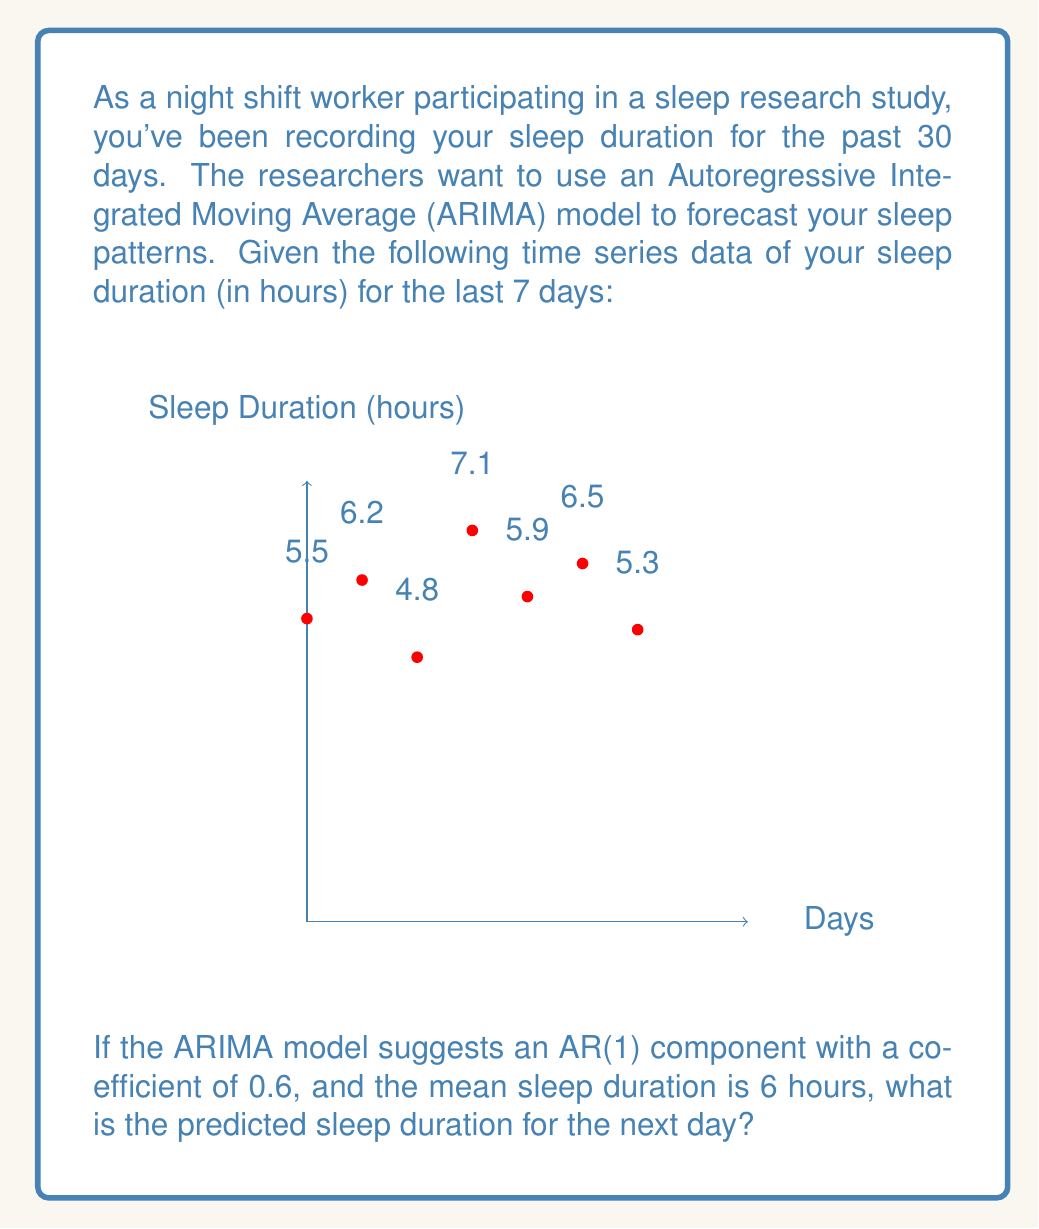What is the answer to this math problem? To solve this problem, we'll use the AR(1) model, which is a component of the ARIMA model. The AR(1) model is given by the equation:

$$ X_t = \mu + \phi(X_{t-1} - \mu) + \epsilon_t $$

Where:
- $X_t$ is the predicted value at time t
- $\mu$ is the mean of the time series
- $\phi$ is the AR(1) coefficient
- $X_{t-1}$ is the previous observed value
- $\epsilon_t$ is the error term (which we assume to be 0 for prediction)

Given:
- $\mu = 6$ hours (mean sleep duration)
- $\phi = 0.6$ (AR(1) coefficient)
- $X_{t-1} = 5.3$ hours (last observed sleep duration)

Step 1: Plug the values into the AR(1) equation:
$$ X_t = 6 + 0.6(5.3 - 6) + 0 $$

Step 2: Simplify the expression inside the parentheses:
$$ X_t = 6 + 0.6(-0.7) + 0 $$

Step 3: Multiply:
$$ X_t = 6 - 0.42 $$

Step 4: Calculate the final result:
$$ X_t = 5.58 $$

Therefore, the predicted sleep duration for the next day is 5.58 hours.
Answer: 5.58 hours 